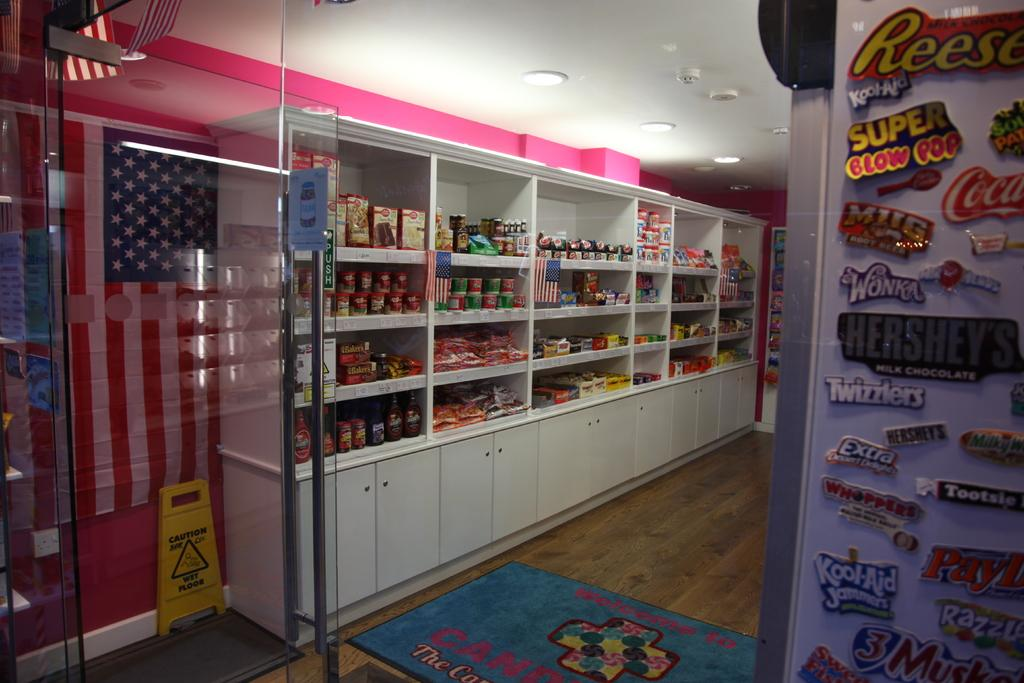<image>
Relay a brief, clear account of the picture shown. the inside of a building with magnets on one side with one that says 'super blow pop' 